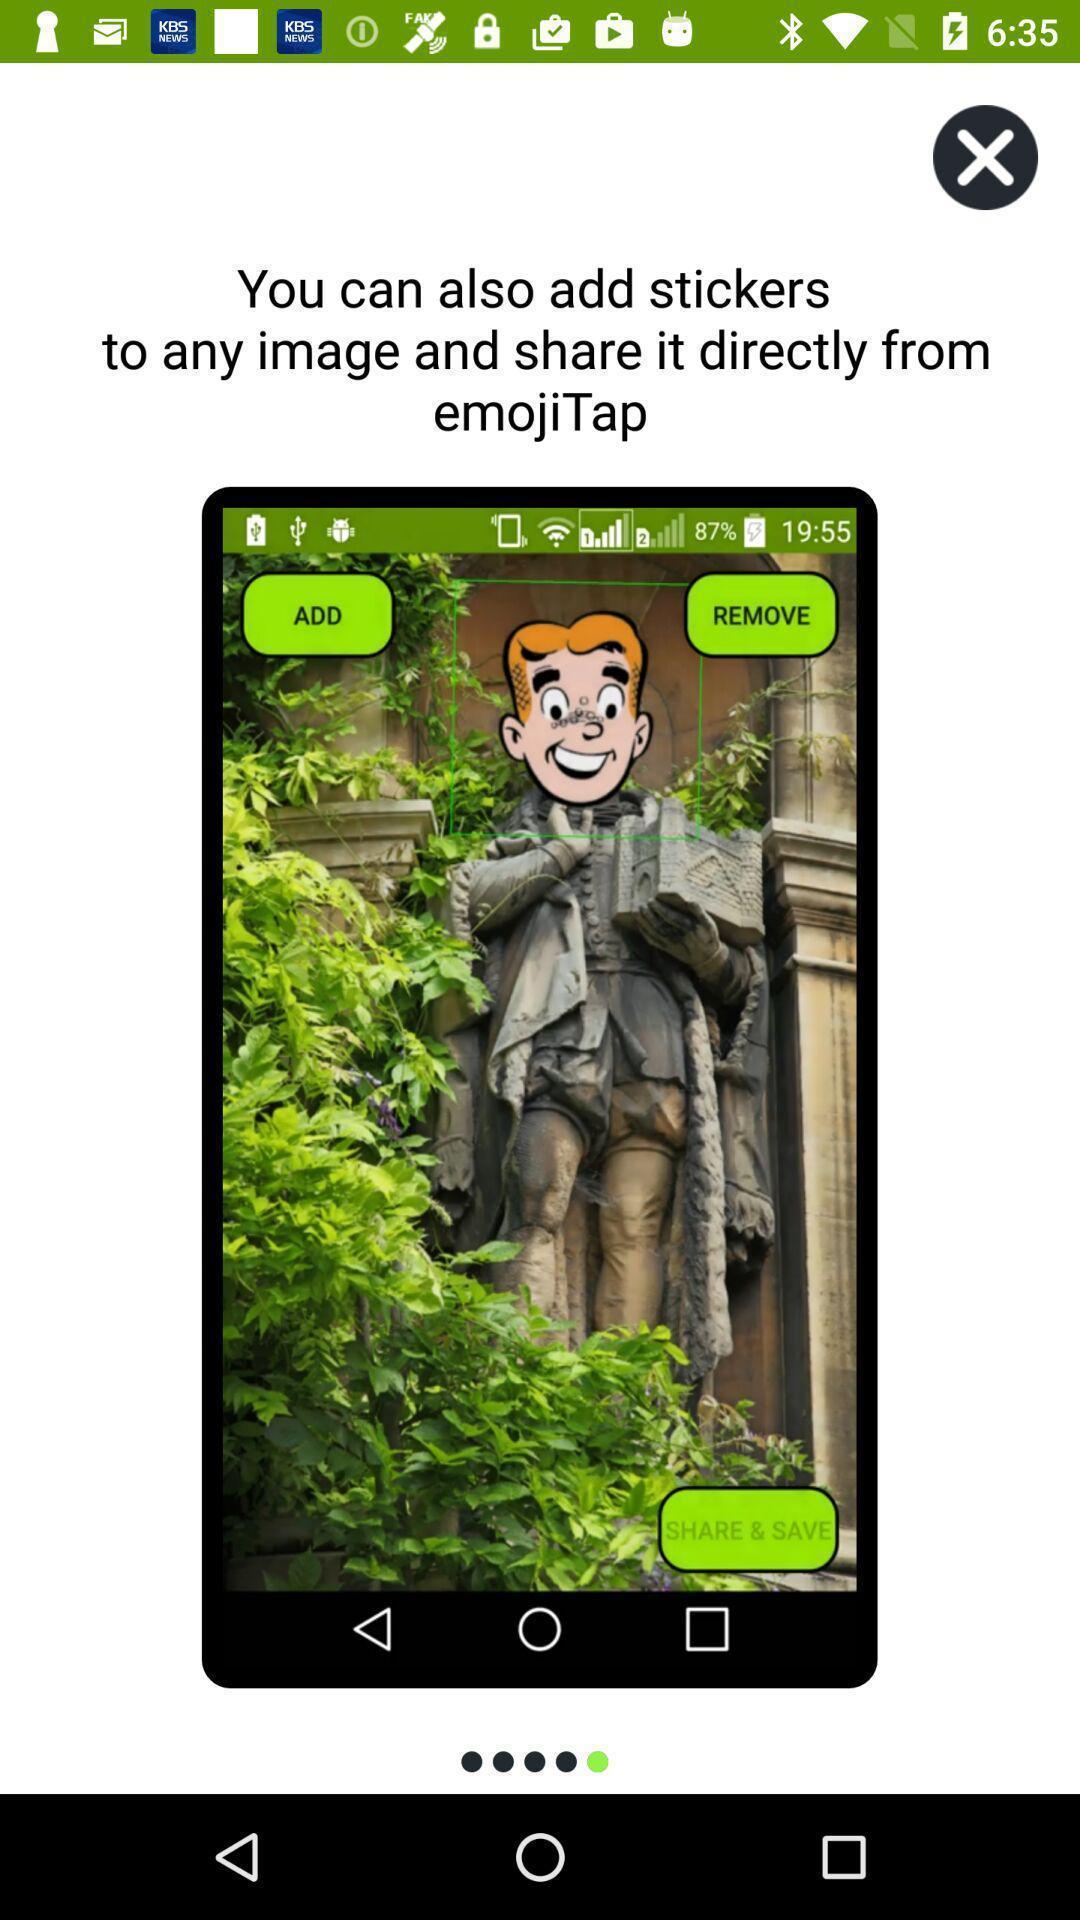Provide a textual representation of this image. Screen shows beginning pages of an stickers app. 